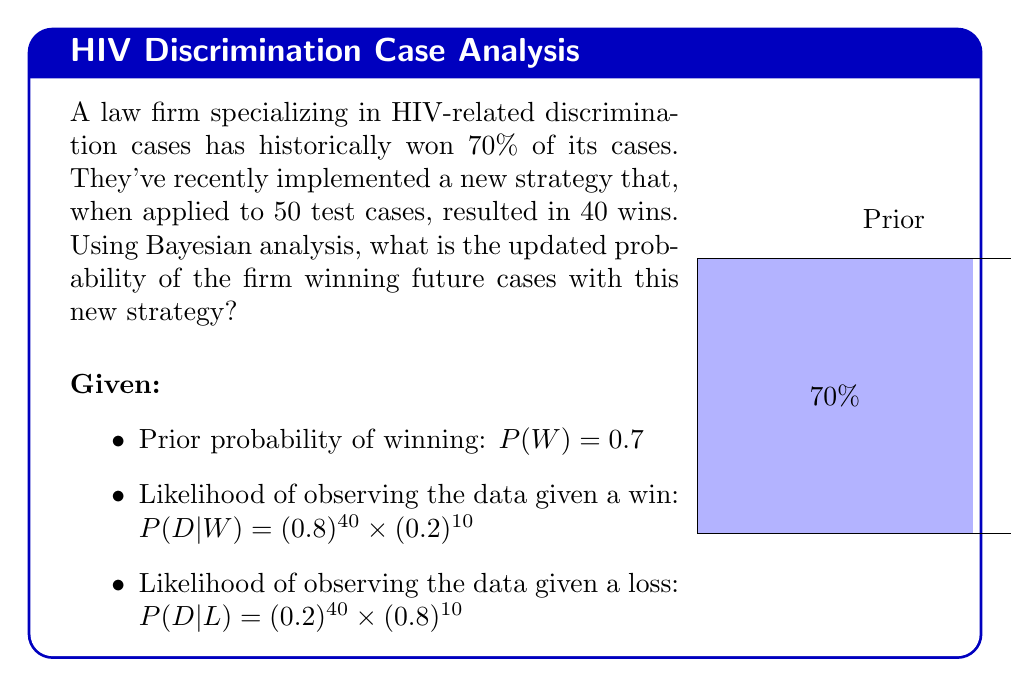Help me with this question. To solve this problem, we'll use Bayes' theorem:

$$P(W|D) = \frac{P(D|W) \times P(W)}{P(D)}$$

Where:
$P(W|D)$ is the posterior probability of winning given the new data
$P(D|W)$ is the likelihood of observing the data given a win
$P(W)$ is the prior probability of winning
$P(D)$ is the total probability of the data

Step 1: Calculate $P(D|W)$ and $P(D|L)$
$P(D|W) = (0.8)^{40} \times (0.2)^{10} \approx 1.5259 \times 10^{-6}$
$P(D|L) = (0.2)^{40} \times (0.8)^{10} \approx 1.0995 \times 10^{-23}$

Step 2: Calculate $P(D)$ using the law of total probability
$P(D) = P(D|W) \times P(W) + P(D|L) \times P(L)$
$P(D) = (1.5259 \times 10^{-6} \times 0.7) + (1.0995 \times 10^{-23} \times 0.3)$
$P(D) \approx 1.0681 \times 10^{-6}$

Step 3: Apply Bayes' theorem
$P(W|D) = \frac{(1.5259 \times 10^{-6}) \times 0.7}{1.0681 \times 10^{-6}}$
$P(W|D) \approx 0.9999$

Therefore, the updated probability of the firm winning future cases with the new strategy is approximately 99.99%.
Answer: $P(W|D) \approx 0.9999$ or 99.99% 